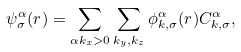<formula> <loc_0><loc_0><loc_500><loc_500>\psi ^ { \alpha } _ { \sigma } ( { r } ) = \sum _ { \alpha k _ { x } > 0 } \sum _ { k _ { y } , k _ { z } } \phi ^ { \alpha } _ { k , \sigma } ( { r } ) C ^ { \alpha } _ { k , \sigma } ,</formula> 